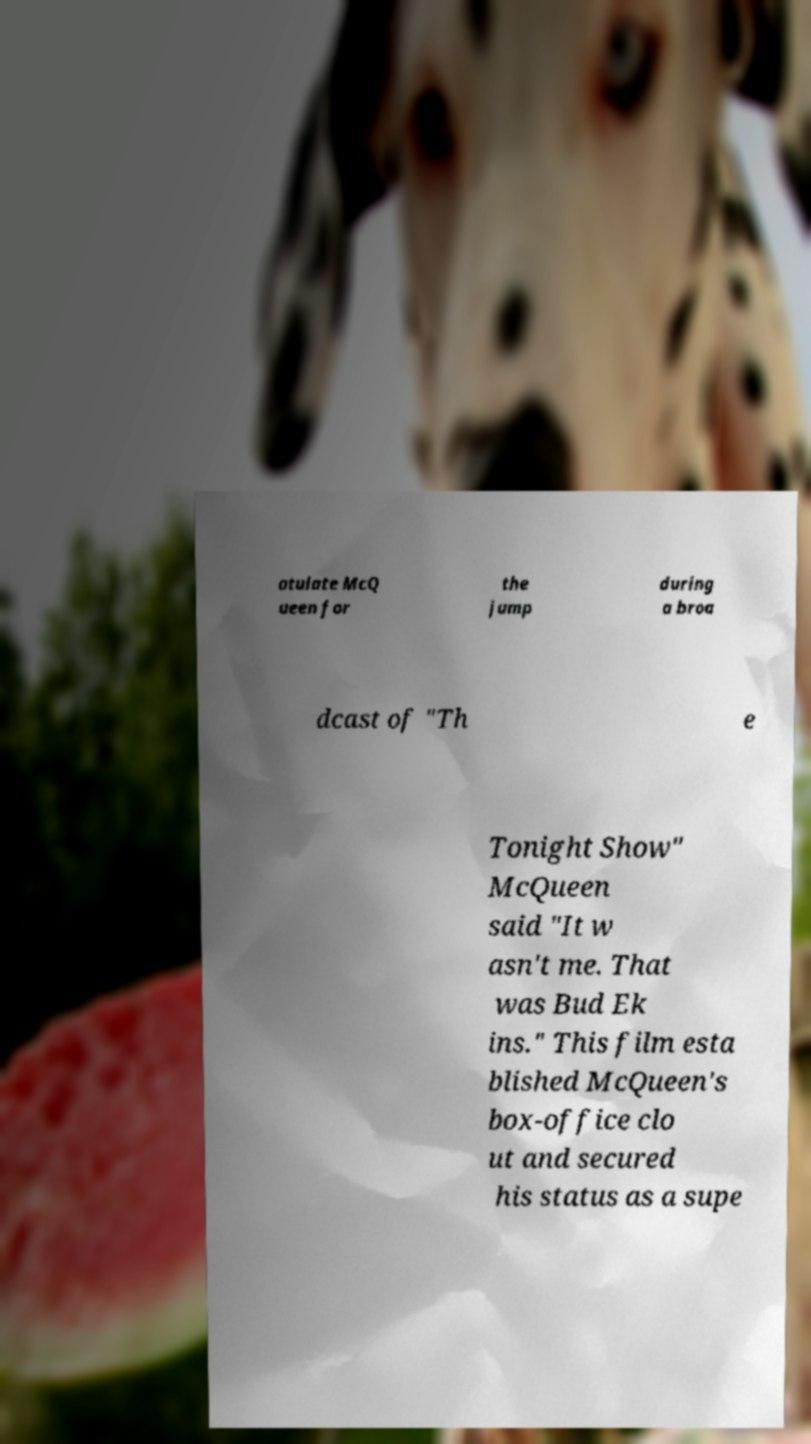Please identify and transcribe the text found in this image. atulate McQ ueen for the jump during a broa dcast of "Th e Tonight Show" McQueen said "It w asn't me. That was Bud Ek ins." This film esta blished McQueen's box-office clo ut and secured his status as a supe 